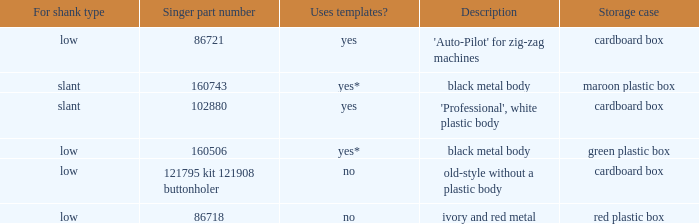Would you be able to parse every entry in this table? {'header': ['For shank type', 'Singer part number', 'Uses templates?', 'Description', 'Storage case'], 'rows': [['low', '86721', 'yes', "'Auto-Pilot' for zig-zag machines", 'cardboard box'], ['slant', '160743', 'yes*', 'black metal body', 'maroon plastic box'], ['slant', '102880', 'yes', "'Professional', white plastic body", 'cardboard box'], ['low', '160506', 'yes*', 'black metal body', 'green plastic box'], ['low', '121795 kit 121908 buttonholer', 'no', 'old-style without a plastic body', 'cardboard box'], ['low', '86718', 'no', 'ivory and red metal', 'red plastic box']]} What are all the different descriptions for the buttonholer with cardboard box for storage and a low shank type? 'Auto-Pilot' for zig-zag machines, old-style without a plastic body. 